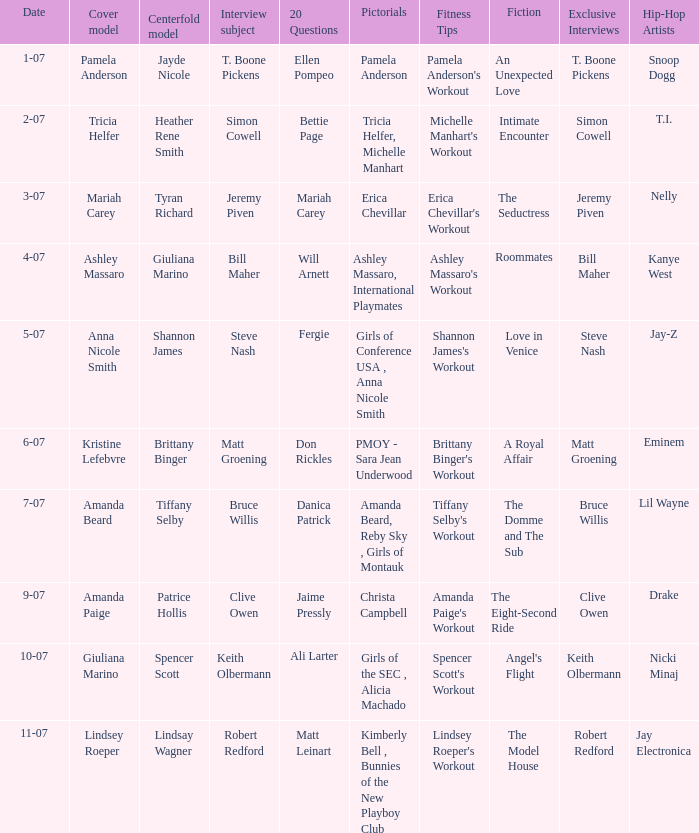Who was the cover model when the issue's pictorials was pmoy - sara jean underwood? Kristine Lefebvre. 